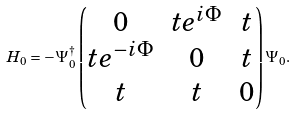Convert formula to latex. <formula><loc_0><loc_0><loc_500><loc_500>H _ { 0 } = - \Psi ^ { \dagger } _ { 0 } \left ( \begin{matrix} 0 & t e ^ { i \Phi } & t \\ t e ^ { - i \Phi } & 0 & t \\ t & t & 0 \end{matrix} \right ) \Psi _ { 0 } .</formula> 